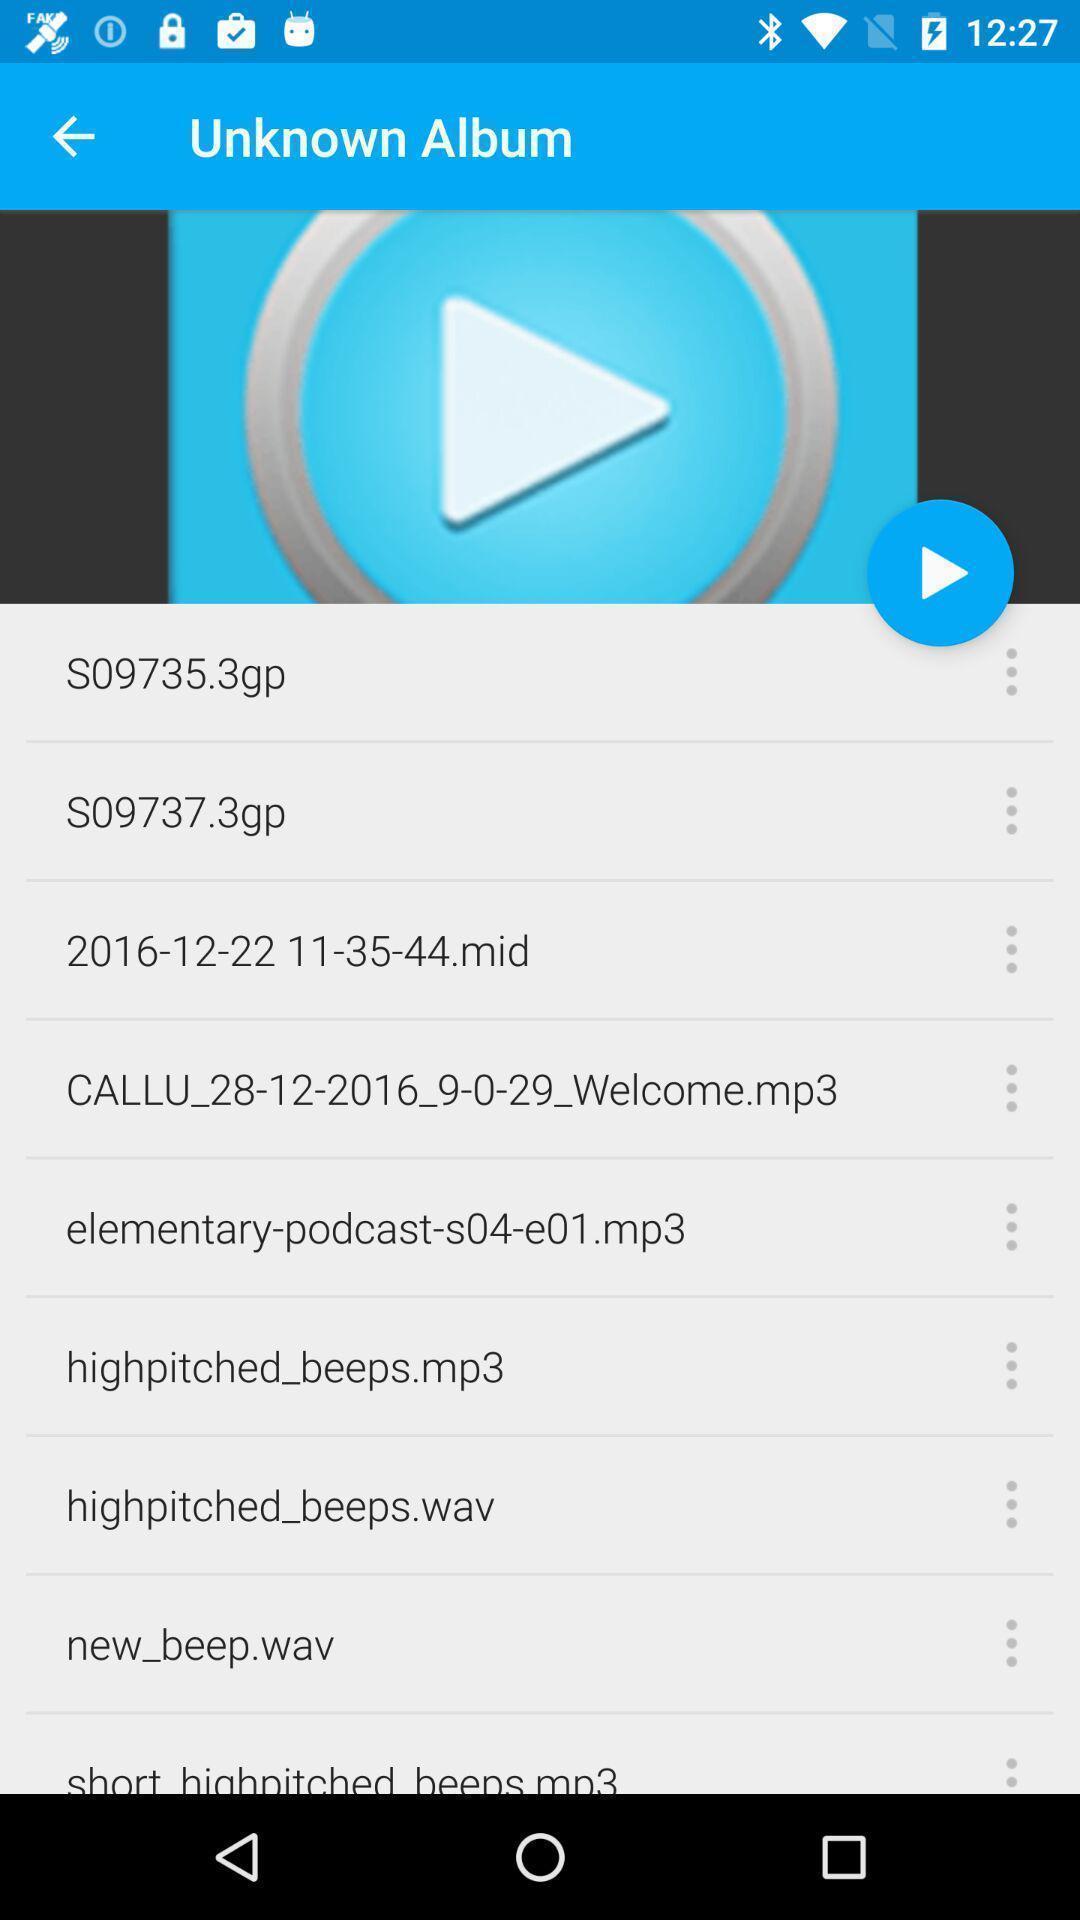Describe the visual elements of this screenshot. Page showing play option. 